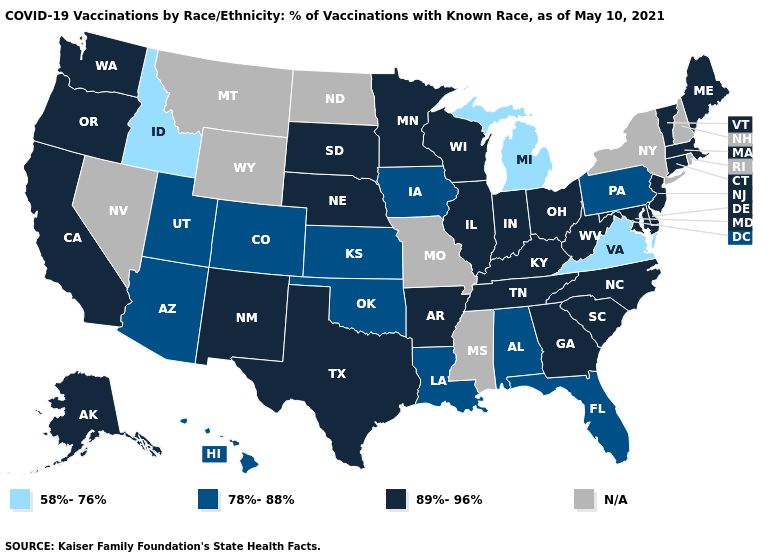What is the highest value in the USA?
Be succinct. 89%-96%. What is the value of Kansas?
Short answer required. 78%-88%. Does Virginia have the lowest value in the USA?
Quick response, please. Yes. What is the highest value in the USA?
Short answer required. 89%-96%. How many symbols are there in the legend?
Keep it brief. 4. What is the value of Florida?
Quick response, please. 78%-88%. Name the states that have a value in the range 78%-88%?
Concise answer only. Alabama, Arizona, Colorado, Florida, Hawaii, Iowa, Kansas, Louisiana, Oklahoma, Pennsylvania, Utah. What is the value of New Hampshire?
Quick response, please. N/A. What is the lowest value in states that border South Carolina?
Concise answer only. 89%-96%. What is the value of Wyoming?
Answer briefly. N/A. Name the states that have a value in the range 89%-96%?
Answer briefly. Alaska, Arkansas, California, Connecticut, Delaware, Georgia, Illinois, Indiana, Kentucky, Maine, Maryland, Massachusetts, Minnesota, Nebraska, New Jersey, New Mexico, North Carolina, Ohio, Oregon, South Carolina, South Dakota, Tennessee, Texas, Vermont, Washington, West Virginia, Wisconsin. 